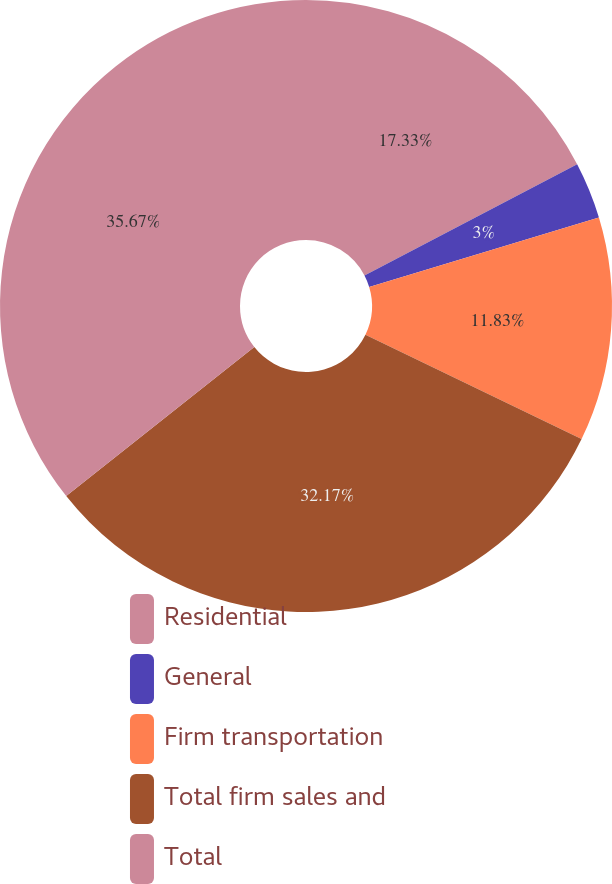<chart> <loc_0><loc_0><loc_500><loc_500><pie_chart><fcel>Residential<fcel>General<fcel>Firm transportation<fcel>Total firm sales and<fcel>Total<nl><fcel>17.33%<fcel>3.0%<fcel>11.83%<fcel>32.17%<fcel>35.67%<nl></chart> 